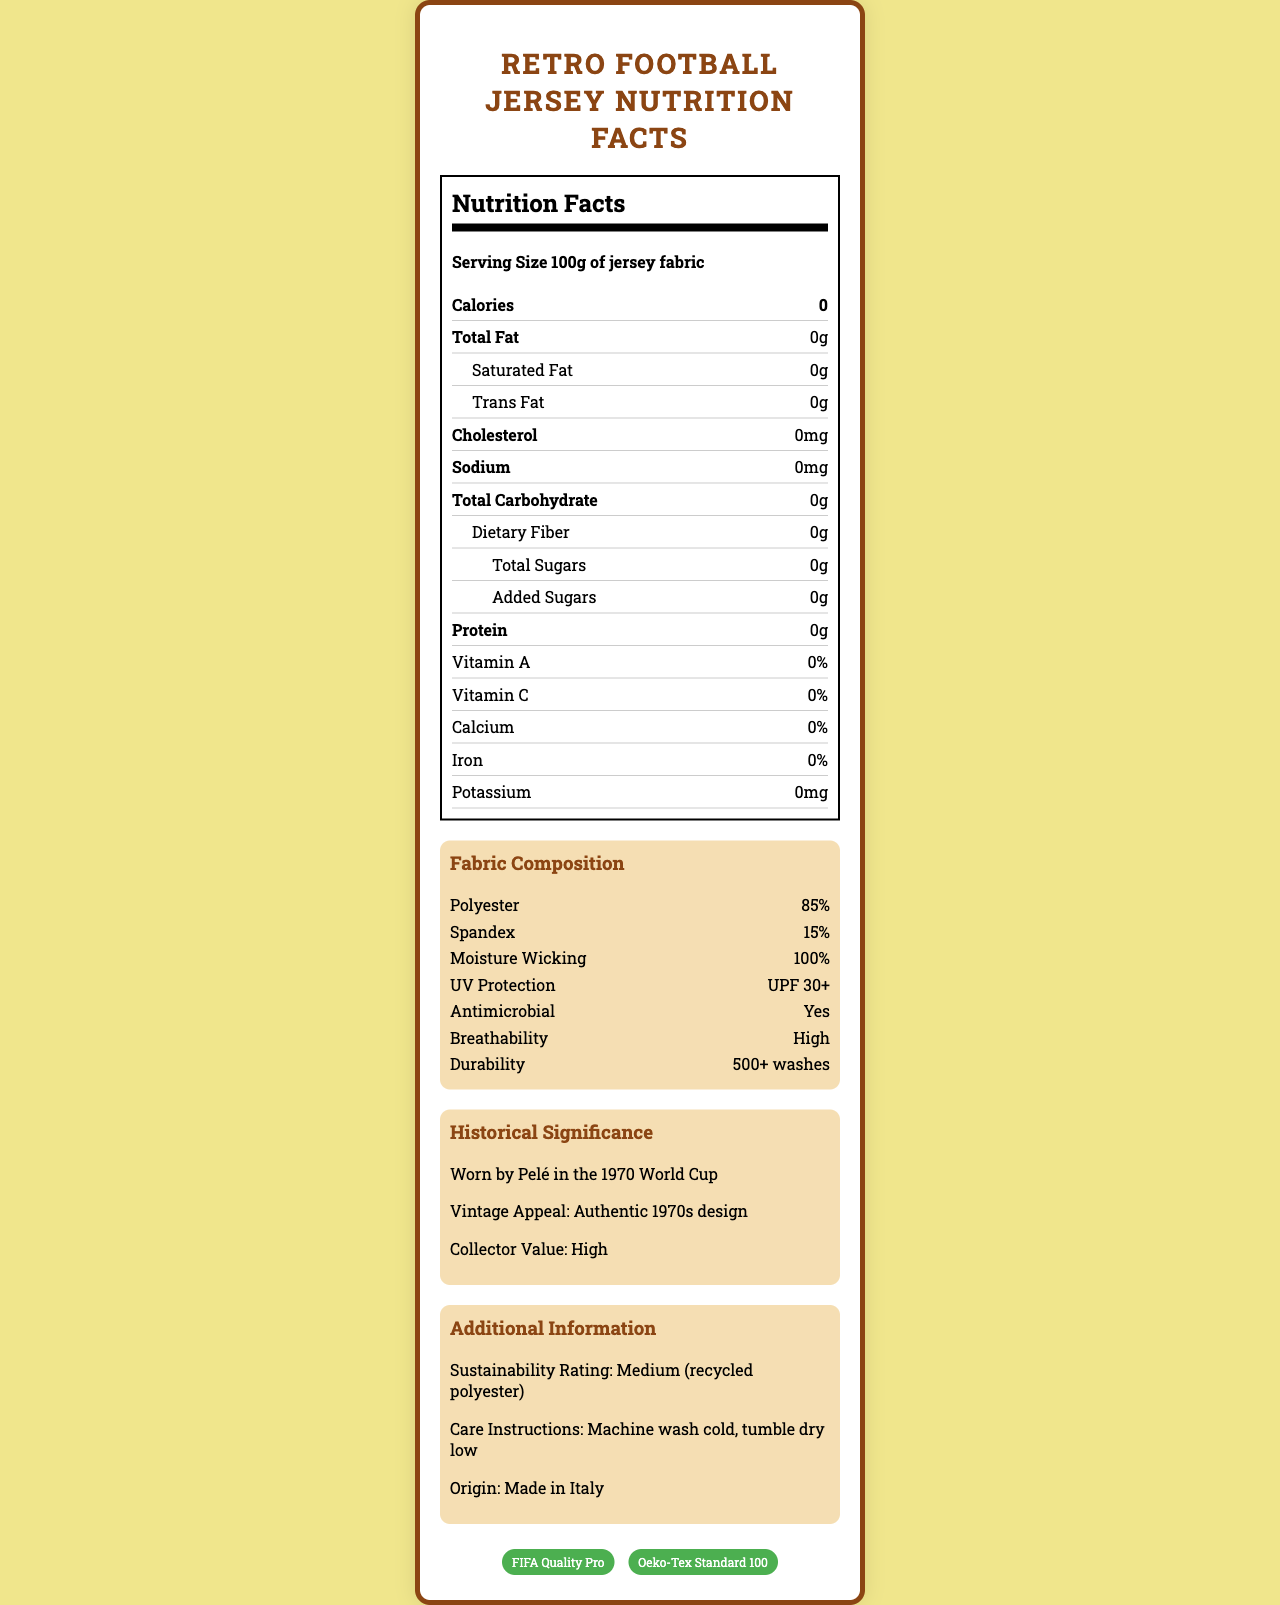what is the serving size of the jersey fabric? The nutritional facts section indicates that the serving size is 100g of jersey fabric.
Answer: 100g how many calories does the jersey fabric contain? The nutrition facts section shows that the jersey fabric contains 0 calories.
Answer: 0 what is the percentage of polyester in the fabric composition? The fabric composition section mentions that the jersey fabric contains 85% polyester.
Answer: 85% does the jersey fabric provide UV protection? The fabric composition section mentions that the UV protection of the jersey fabric is UPF 30+.
Answer: Yes how many washes can the jersey fabric endure? The fabric composition section states that the durability of the jersey fabric is 500+ washes.
Answer: 500+ what is the historical significance of this jersey fabric? The historical significance section notes that this jersey fabric was worn by Pelé in the 1970 World Cup.
Answer: Worn by Pelé in the 1970 World Cup what is the collector value of this jersey fabric? A. Low B. Medium C. High The historical significance section lists that the collector value of the jersey fabric is high.
Answer: C which country is this jersey fabric made in? A. USA B. Italy C. Brazil D. Germany The additional information section states that the jersey fabric is made in Italy.
Answer: B is the jersey fabric antimicrobial? The fabric composition section indicates that the jersey fabric is antimicrobial.
Answer: Yes summarize the document. The document includes details such as serving size, serving per container, calorie count, and various nutritional facts, all of which are 0. It provides fabric composition information, including polyester and spandex content, moisture-wicking properties, UV protection, antimicrobial features, breathability, and durability. It explains the historical significance of the fabric, emphasizing its use by Pelé in the 1970 World Cup, and states its high collector value. It also includes care instructions, sustainability rating, origin country, and certifications.
Answer: The document presents the nutritional facts and fabric composition of a retro football jersey with sweat-wicking properties, focusing on its historical and collector significance. how many added sugars does the jersey fabric contain? The nutrition facts section indicates that the jersey fabric contains 0g of added sugars.
Answer: 0g can the exact date of the jersey's origin be determined from the document? The document does not provide an exact date for when the jersey fabric was made; it only provides historical context and origin country.
Answer: Cannot be determined which certifications does the jersey fabric hold? The certifications section lists FIFA Quality Pro and Oeko-Tex Standard 100 as the certifications held by the jersey fabric.
Answer: FIFA Quality Pro and Oeko-Tex Standard 100 what are the care instructions for the jersey fabric? The additional information section provides the care instructions for the jersey fabric: machine wash cold, tumble dry low.
Answer: Machine wash cold, tumble dry low what is the total carbohydrate content of the fabric? The nutrition facts section indicates that the total carbohydrate content is 0g.
Answer: 0g what rating does the jersey receive for sustainability? The additional information section states that the sustainability rating is medium, as it is made with recycled polyester.
Answer: Medium (recycled polyester) 